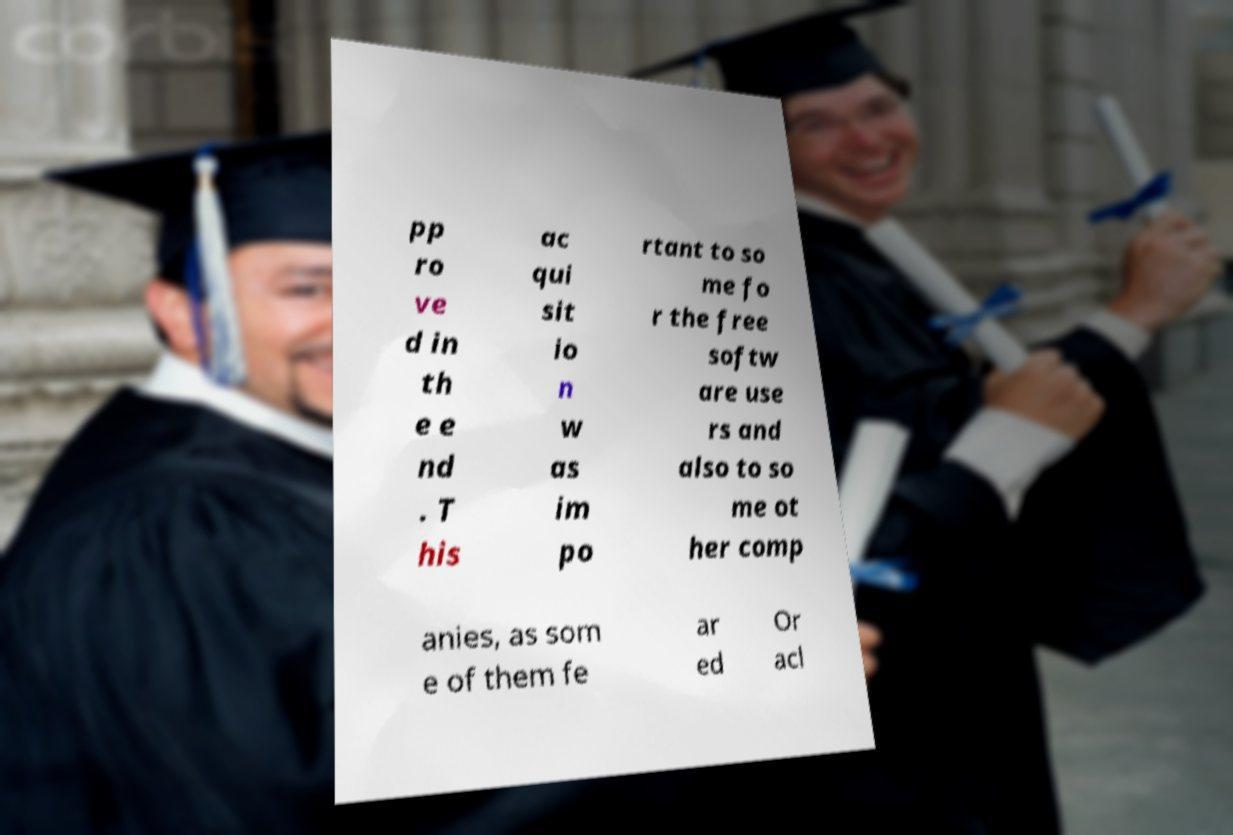What messages or text are displayed in this image? I need them in a readable, typed format. pp ro ve d in th e e nd . T his ac qui sit io n w as im po rtant to so me fo r the free softw are use rs and also to so me ot her comp anies, as som e of them fe ar ed Or acl 